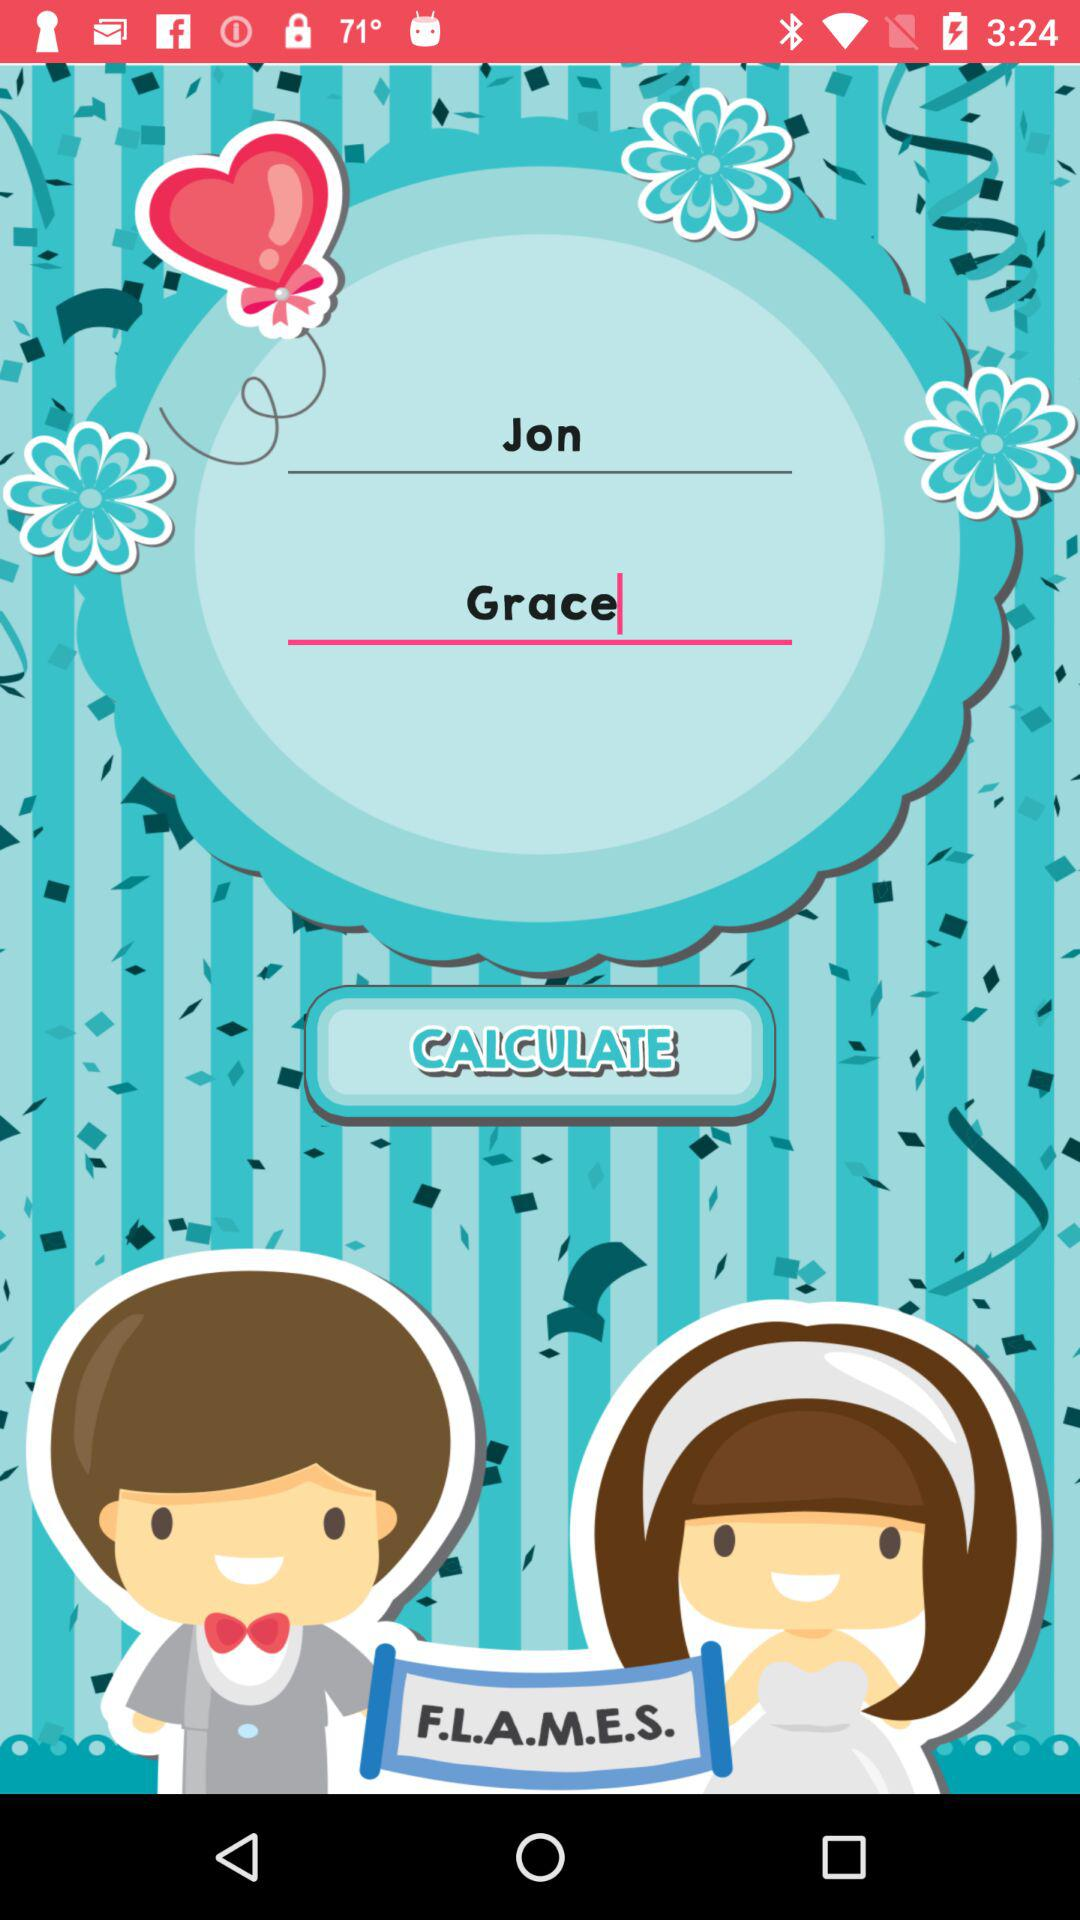Which game is shown? The shown game is "F.L.A.M.E.S.". 